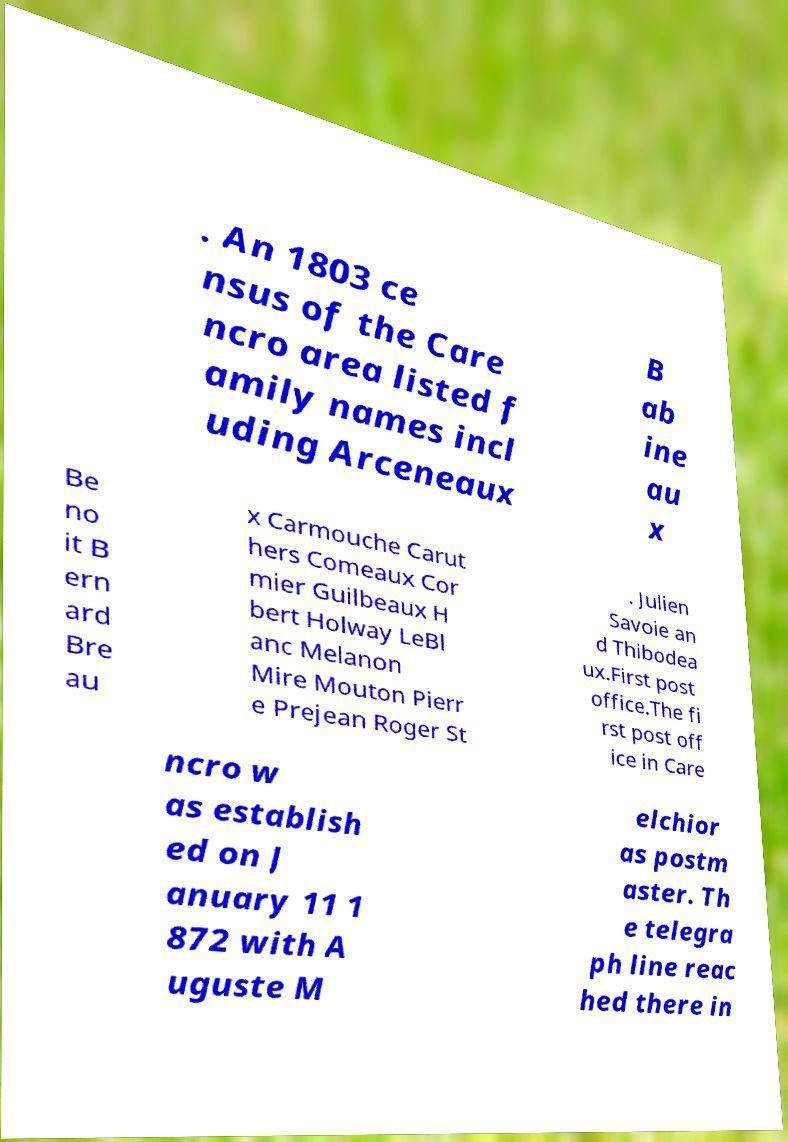Could you assist in decoding the text presented in this image and type it out clearly? . An 1803 ce nsus of the Care ncro area listed f amily names incl uding Arceneaux B ab ine au x Be no it B ern ard Bre au x Carmouche Carut hers Comeaux Cor mier Guilbeaux H bert Holway LeBl anc Melanon Mire Mouton Pierr e Prejean Roger St . Julien Savoie an d Thibodea ux.First post office.The fi rst post off ice in Care ncro w as establish ed on J anuary 11 1 872 with A uguste M elchior as postm aster. Th e telegra ph line reac hed there in 